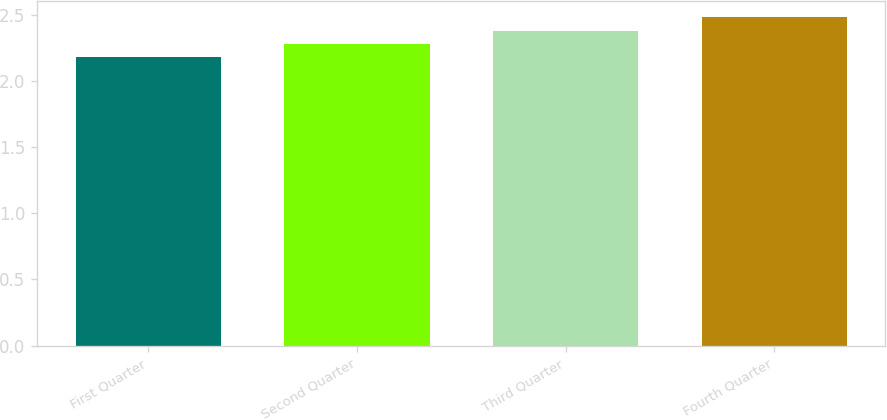<chart> <loc_0><loc_0><loc_500><loc_500><bar_chart><fcel>First Quarter<fcel>Second Quarter<fcel>Third Quarter<fcel>Fourth Quarter<nl><fcel>2.18<fcel>2.28<fcel>2.38<fcel>2.48<nl></chart> 